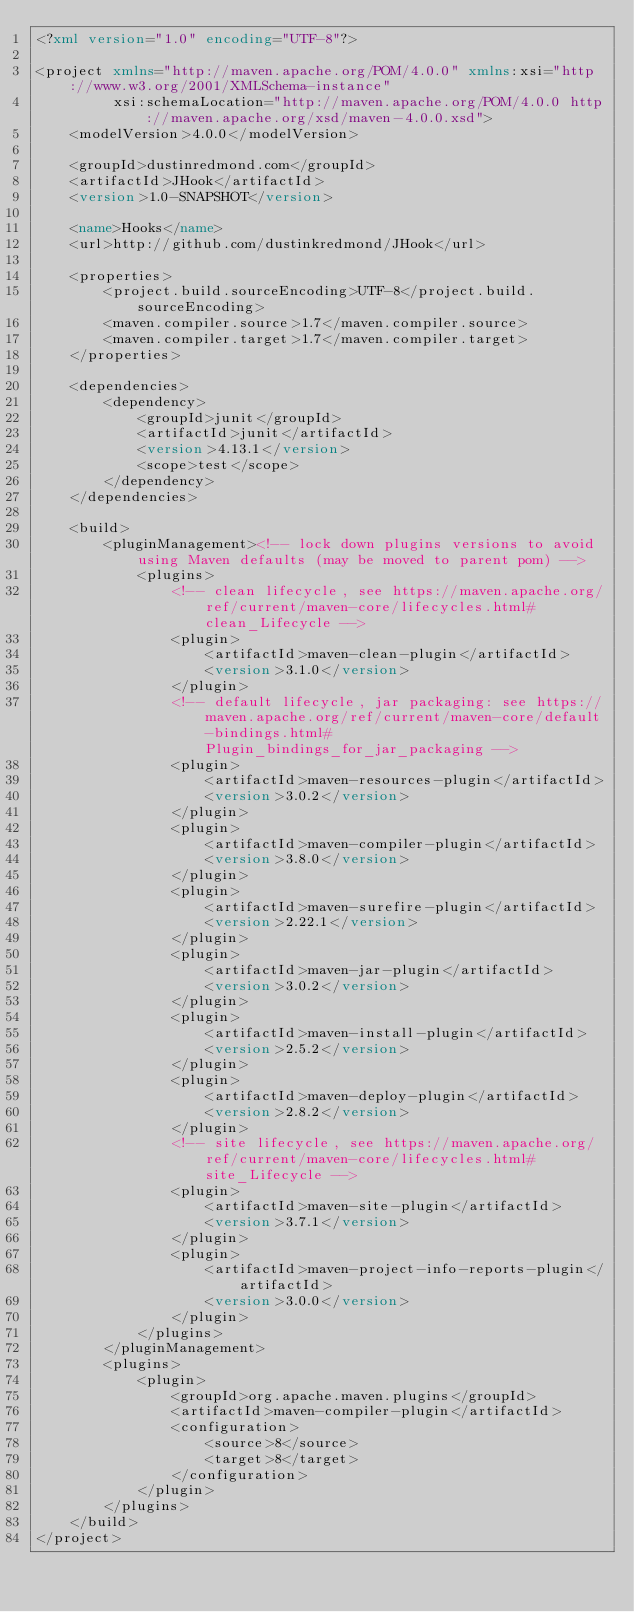Convert code to text. <code><loc_0><loc_0><loc_500><loc_500><_XML_><?xml version="1.0" encoding="UTF-8"?>

<project xmlns="http://maven.apache.org/POM/4.0.0" xmlns:xsi="http://www.w3.org/2001/XMLSchema-instance"
         xsi:schemaLocation="http://maven.apache.org/POM/4.0.0 http://maven.apache.org/xsd/maven-4.0.0.xsd">
    <modelVersion>4.0.0</modelVersion>

    <groupId>dustinredmond.com</groupId>
    <artifactId>JHook</artifactId>
    <version>1.0-SNAPSHOT</version>

    <name>Hooks</name>
    <url>http://github.com/dustinkredmond/JHook</url>

    <properties>
        <project.build.sourceEncoding>UTF-8</project.build.sourceEncoding>
        <maven.compiler.source>1.7</maven.compiler.source>
        <maven.compiler.target>1.7</maven.compiler.target>
    </properties>

    <dependencies>
        <dependency>
            <groupId>junit</groupId>
            <artifactId>junit</artifactId>
            <version>4.13.1</version>
            <scope>test</scope>
        </dependency>
    </dependencies>

    <build>
        <pluginManagement><!-- lock down plugins versions to avoid using Maven defaults (may be moved to parent pom) -->
            <plugins>
                <!-- clean lifecycle, see https://maven.apache.org/ref/current/maven-core/lifecycles.html#clean_Lifecycle -->
                <plugin>
                    <artifactId>maven-clean-plugin</artifactId>
                    <version>3.1.0</version>
                </plugin>
                <!-- default lifecycle, jar packaging: see https://maven.apache.org/ref/current/maven-core/default-bindings.html#Plugin_bindings_for_jar_packaging -->
                <plugin>
                    <artifactId>maven-resources-plugin</artifactId>
                    <version>3.0.2</version>
                </plugin>
                <plugin>
                    <artifactId>maven-compiler-plugin</artifactId>
                    <version>3.8.0</version>
                </plugin>
                <plugin>
                    <artifactId>maven-surefire-plugin</artifactId>
                    <version>2.22.1</version>
                </plugin>
                <plugin>
                    <artifactId>maven-jar-plugin</artifactId>
                    <version>3.0.2</version>
                </plugin>
                <plugin>
                    <artifactId>maven-install-plugin</artifactId>
                    <version>2.5.2</version>
                </plugin>
                <plugin>
                    <artifactId>maven-deploy-plugin</artifactId>
                    <version>2.8.2</version>
                </plugin>
                <!-- site lifecycle, see https://maven.apache.org/ref/current/maven-core/lifecycles.html#site_Lifecycle -->
                <plugin>
                    <artifactId>maven-site-plugin</artifactId>
                    <version>3.7.1</version>
                </plugin>
                <plugin>
                    <artifactId>maven-project-info-reports-plugin</artifactId>
                    <version>3.0.0</version>
                </plugin>
            </plugins>
        </pluginManagement>
        <plugins>
            <plugin>
                <groupId>org.apache.maven.plugins</groupId>
                <artifactId>maven-compiler-plugin</artifactId>
                <configuration>
                    <source>8</source>
                    <target>8</target>
                </configuration>
            </plugin>
        </plugins>
    </build>
</project>
</code> 